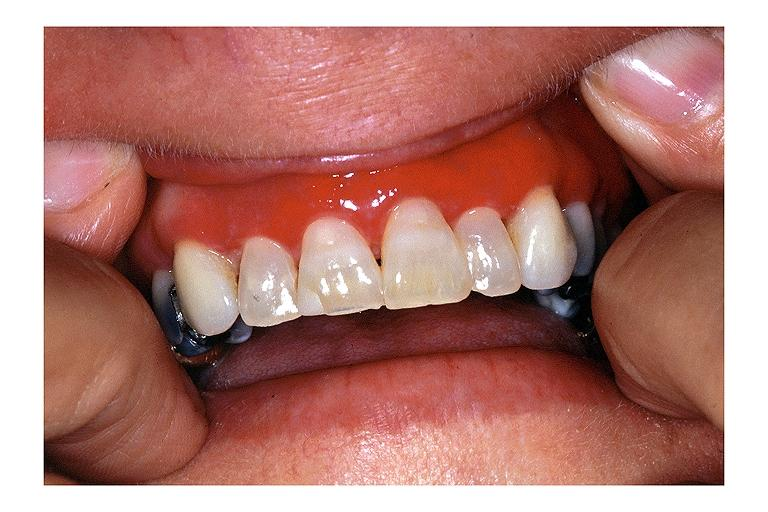s cranial artery present?
Answer the question using a single word or phrase. No 